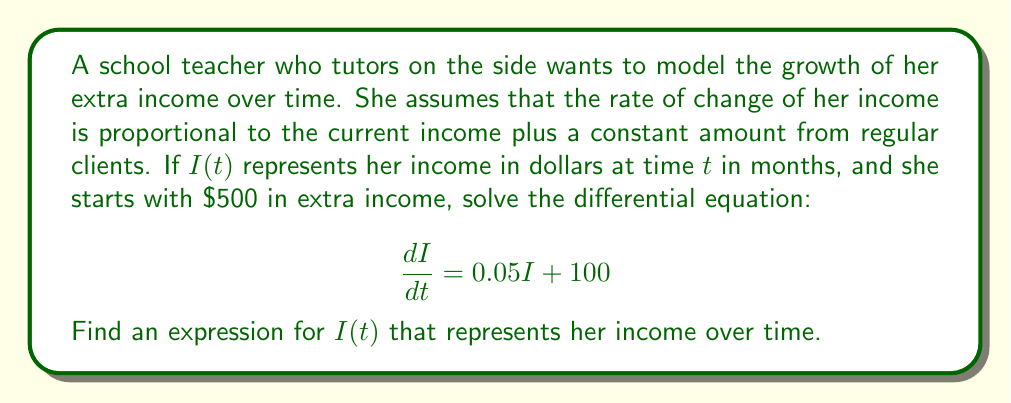Help me with this question. To solve this first-order linear differential equation, we'll use the integrating factor method:

1) First, identify the equation in the standard form:
   $$\frac{dI}{dt} + P(t)I = Q(t)$$
   Here, $P(t) = -0.05$ and $Q(t) = 100$

2) Calculate the integrating factor:
   $$\mu(t) = e^{\int P(t) dt} = e^{\int -0.05 dt} = e^{-0.05t}$$

3) Multiply both sides of the original equation by $\mu(t)$:
   $$e^{-0.05t}\frac{dI}{dt} - 0.05e^{-0.05t}I = 100e^{-0.05t}$$

4) Recognize that the left side is the derivative of $e^{-0.05t}I$:
   $$\frac{d}{dt}(e^{-0.05t}I) = 100e^{-0.05t}$$

5) Integrate both sides:
   $$e^{-0.05t}I = -2000e^{-0.05t} + C$$

6) Solve for $I(t)$:
   $$I(t) = -2000 + Ce^{0.05t}$$

7) Use the initial condition $I(0) = 500$ to find $C$:
   $$500 = -2000 + C$$
   $$C = 2500$$

8) Write the final solution:
   $$I(t) = -2000 + 2500e^{0.05t}$$

9) Simplify:
   $$I(t) = 2000(e^{0.05t} - 1) + 500e^{0.05t}$$
Answer: $I(t) = 2000(e^{0.05t} - 1) + 500e^{0.05t}$ 